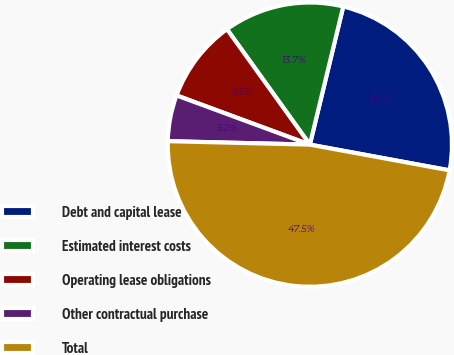Convert chart. <chart><loc_0><loc_0><loc_500><loc_500><pie_chart><fcel>Debt and capital lease<fcel>Estimated interest costs<fcel>Operating lease obligations<fcel>Other contractual purchase<fcel>Total<nl><fcel>24.12%<fcel>13.69%<fcel>9.46%<fcel>5.24%<fcel>47.49%<nl></chart> 